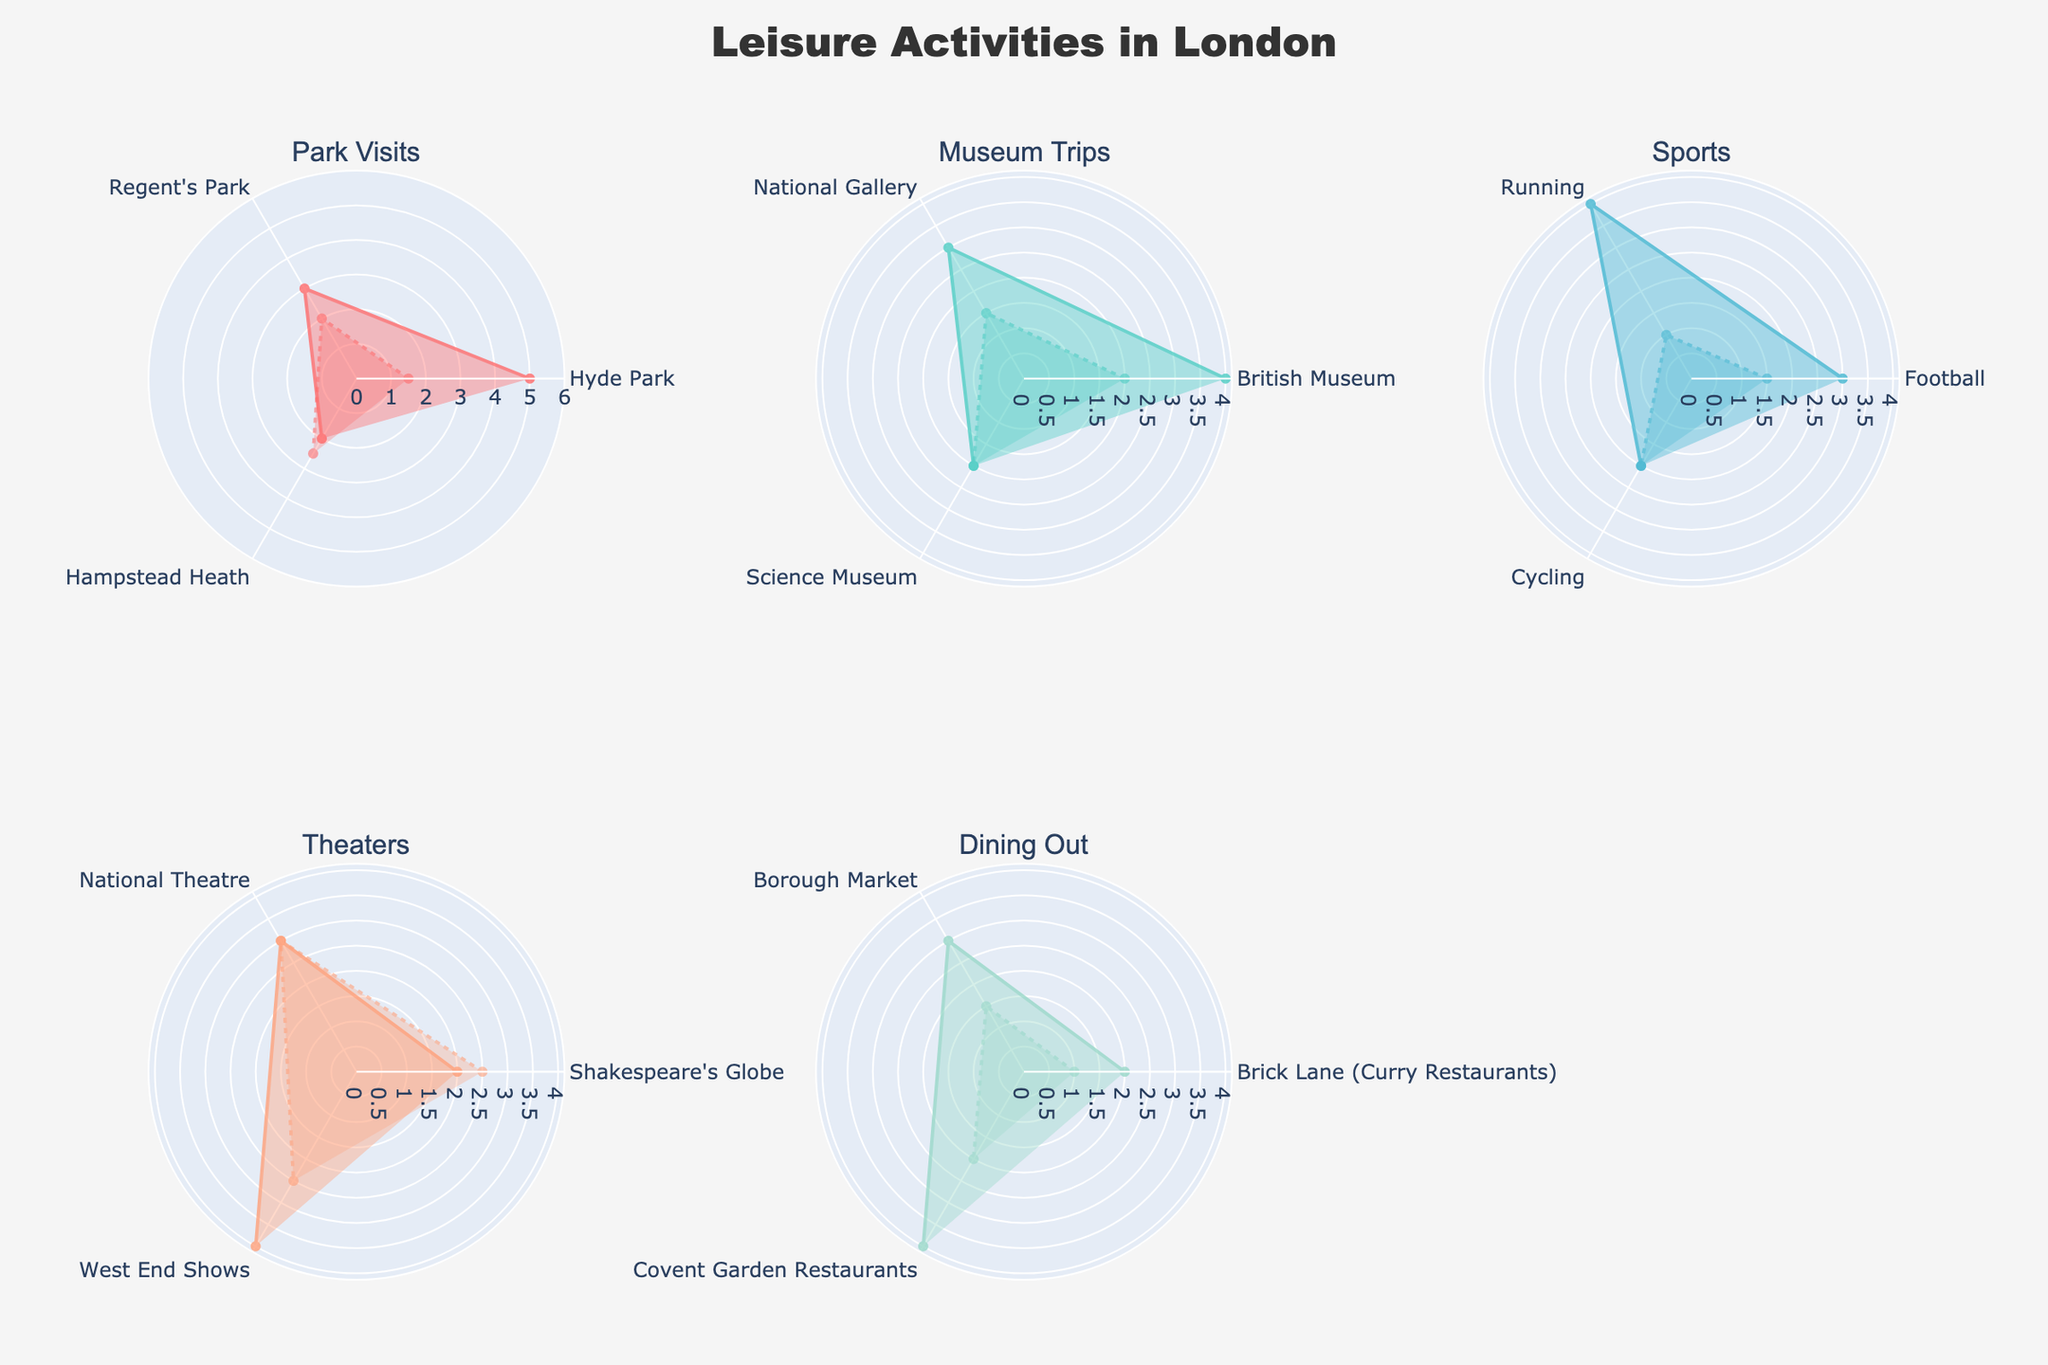What's the title of the chart? The title is usually at the top of the figure. Here, the title is clearly indicated as "Leisure Activities in London".
Answer: Leisure Activities in London What are the categories of leisure activities shown in the subplots? By examining the subplot titles, we can identify the categories as Park Visits, Museum Trips, Sports, Theaters, and Dining Out.
Answer: Park Visits, Museum Trips, Sports, Theaters, Dining Out Which park has the highest frequency of visits? From the radar plot for Park Visits, we can see that Hyde Park has the highest frequency of 5.
Answer: Hyde Park What leisure activity under 'Theaters' has the longest average duration per session? By looking at the 'Theaters' radar plot, we can see that the National Theatre has the longest average duration per session of 3 hours.
Answer: National Theatre How does the frequency of visiting the British Museum compare to that of visiting West End shows? Referring to the radar charts for Museum Trips and Theaters, the frequency of visits to the British Museum is 4, which is the same as the frequency of visiting West End shows.
Answer: Equal Which dining out location has the shortest average duration per session? In the Dining Out radar plot, Brick Lane has the shortest average duration per session of 1 hour.
Answer: Brick Lane What is the average frequency of all the sports activities listed? Summing the frequencies of Football (3), Running (4), and Cycling (2) gives us a total of 9. Dividing this by the 3 activities, the average frequency is 3.
Answer: 3 Compare the frequencies of Hyde Park visits and running sessions. Which one is more frequent and by how much? Hyde Park has a frequency of 5, while running sessions have a frequency of 4. Thus, Hyde Park visits are more frequent by 1.
Answer: Hyde Park, by 1 Identify the leisure activity with the highest overall frequency among all categories. By scanning all the radar charts, the highest frequency observed is 5, which is for Hyde Park under Park Visits.
Answer: Hyde Park 